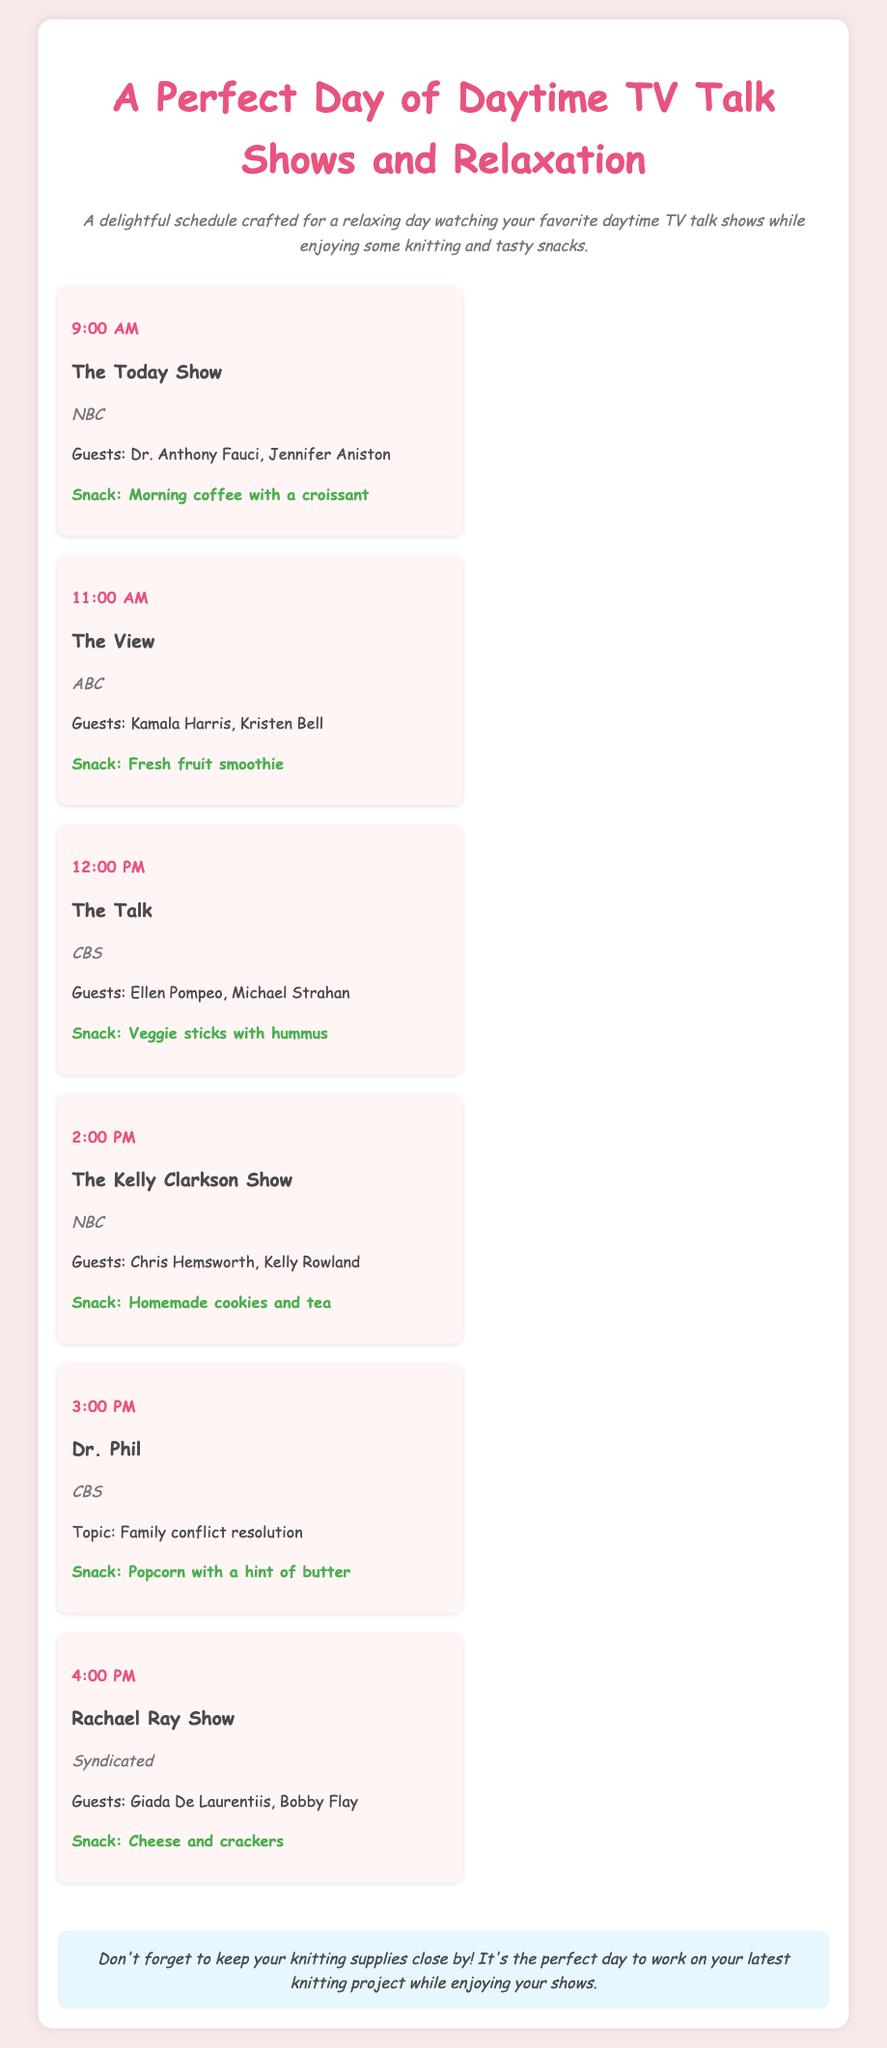What time does The Today Show air? The Today Show is scheduled at 9:00 AM in the itinerary.
Answer: 9:00 AM Who are the guests on The View? The guests listed for The View are Kamala Harris and Kristen Bell.
Answer: Kamala Harris, Kristen Bell What snack is suggested while watching The Talk? The Talk includes the snack of veggie sticks with hummus.
Answer: Veggie sticks with hummus Which show features Dr. Phil? Dr. Phil is mentioned in the schedule as airing at 3:00 PM.
Answer: Dr. Phil How many shows are scheduled before 2:00 PM? There are four shows scheduled before 2:00 PM: The Today Show, The View, The Talk, and The Kelly Clarkson Show.
Answer: 4 Which network broadcasts The Kelly Clarkson Show? The Kelly Clarkson Show is broadcasted on NBC.
Answer: NBC What type of snack is mentioned for the 4:00 PM show? The snack for Rachael Ray Show at 4:00 PM is cheese and crackers.
Answer: Cheese and crackers What is the overall theme of the document? The document outlines a perfect day for watching daytime TV talk shows while enjoying snacks and knitting.
Answer: A perfect day of daytime TV talk shows and relaxation 